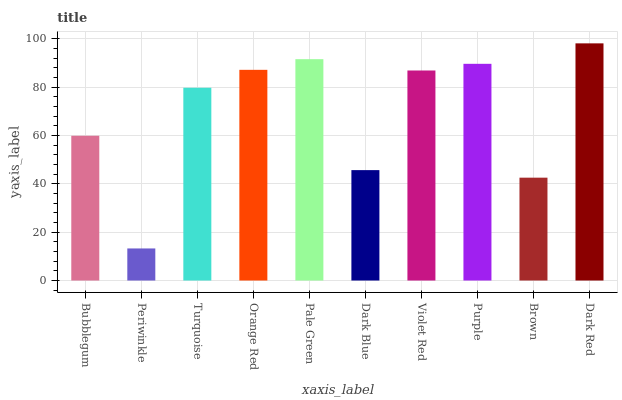Is Turquoise the minimum?
Answer yes or no. No. Is Turquoise the maximum?
Answer yes or no. No. Is Turquoise greater than Periwinkle?
Answer yes or no. Yes. Is Periwinkle less than Turquoise?
Answer yes or no. Yes. Is Periwinkle greater than Turquoise?
Answer yes or no. No. Is Turquoise less than Periwinkle?
Answer yes or no. No. Is Violet Red the high median?
Answer yes or no. Yes. Is Turquoise the low median?
Answer yes or no. Yes. Is Turquoise the high median?
Answer yes or no. No. Is Purple the low median?
Answer yes or no. No. 